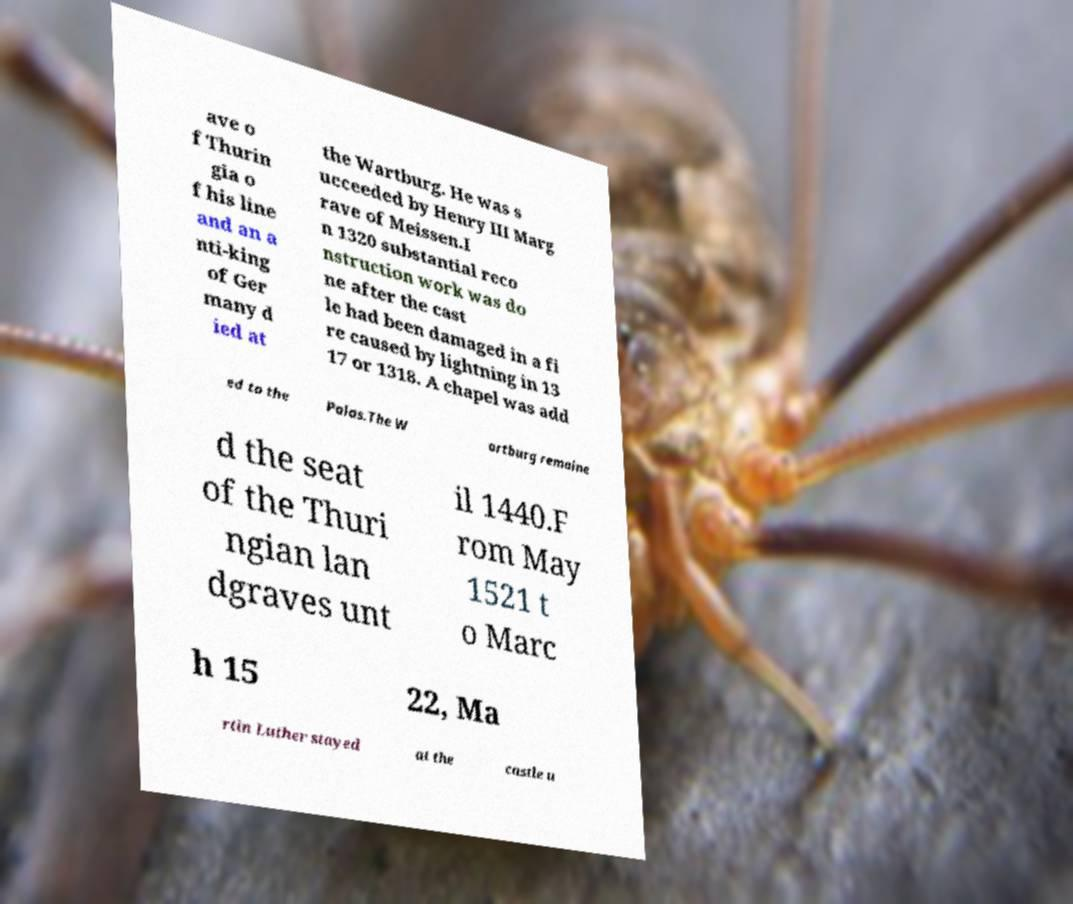What messages or text are displayed in this image? I need them in a readable, typed format. ave o f Thurin gia o f his line and an a nti-king of Ger many d ied at the Wartburg. He was s ucceeded by Henry III Marg rave of Meissen.I n 1320 substantial reco nstruction work was do ne after the cast le had been damaged in a fi re caused by lightning in 13 17 or 1318. A chapel was add ed to the Palas.The W artburg remaine d the seat of the Thuri ngian lan dgraves unt il 1440.F rom May 1521 t o Marc h 15 22, Ma rtin Luther stayed at the castle u 